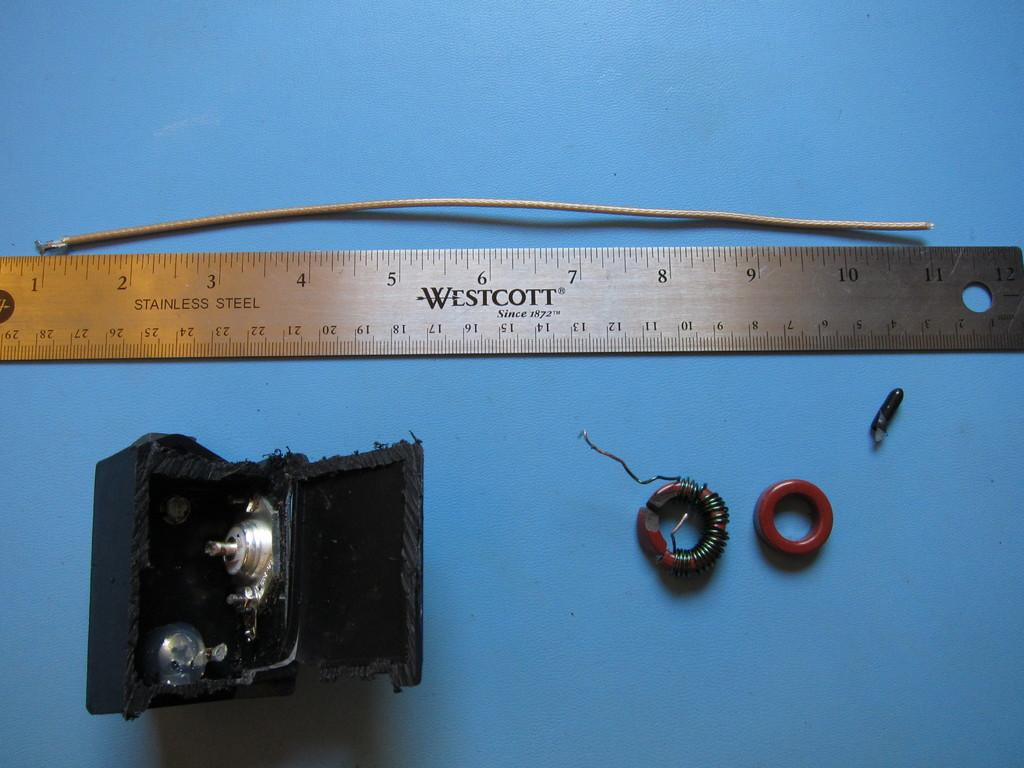<image>
Give a short and clear explanation of the subsequent image. A stainless steel ruler is made by the Westcott company, which has been in business since 1872. 